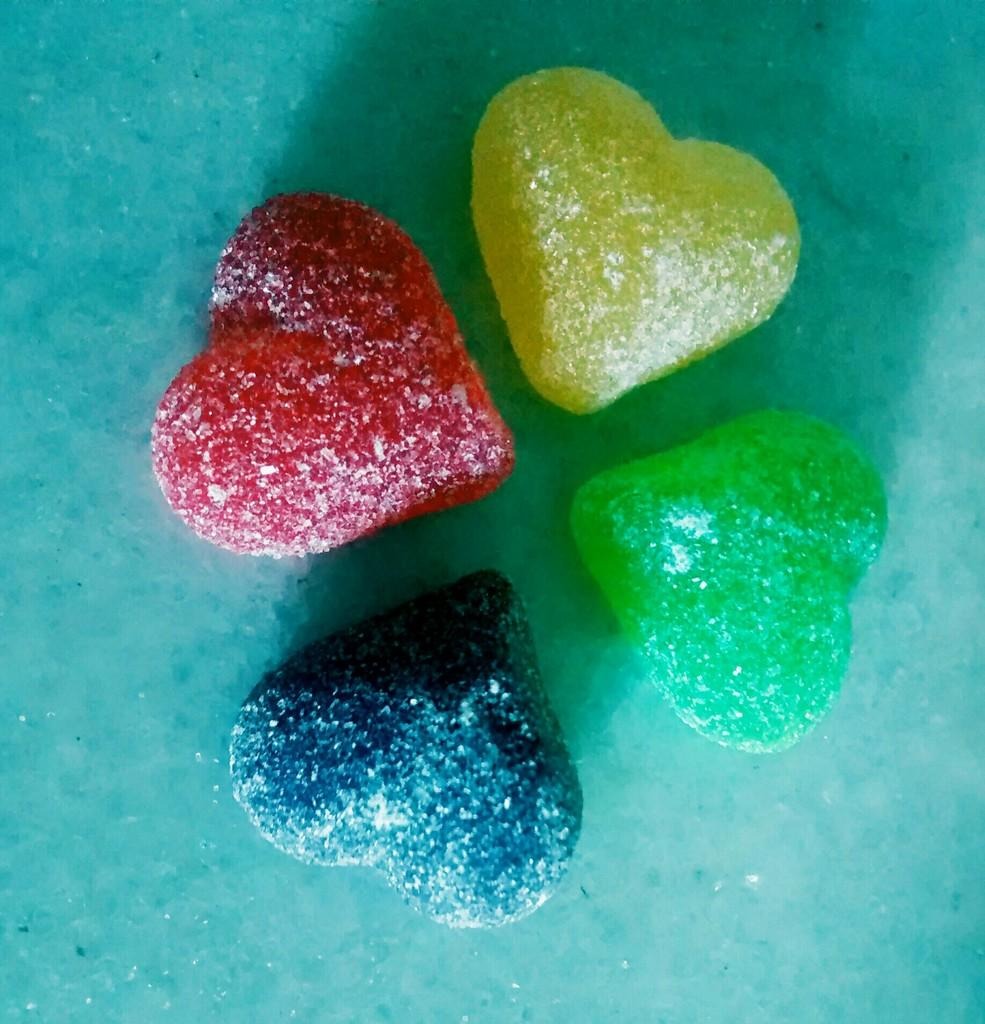What type of objects are in the image? There are colorful candies in the image. What is the color of the surface on which the candies are placed? The candies are on a blue surface. What type of medical equipment can be seen in the image? There is no medical equipment present in the image; it features colorful candies on a blue surface. Where might the candies be served during lunchtime? The image does not provide information about where the candies might be served, nor does it depict a lunchroom setting. 